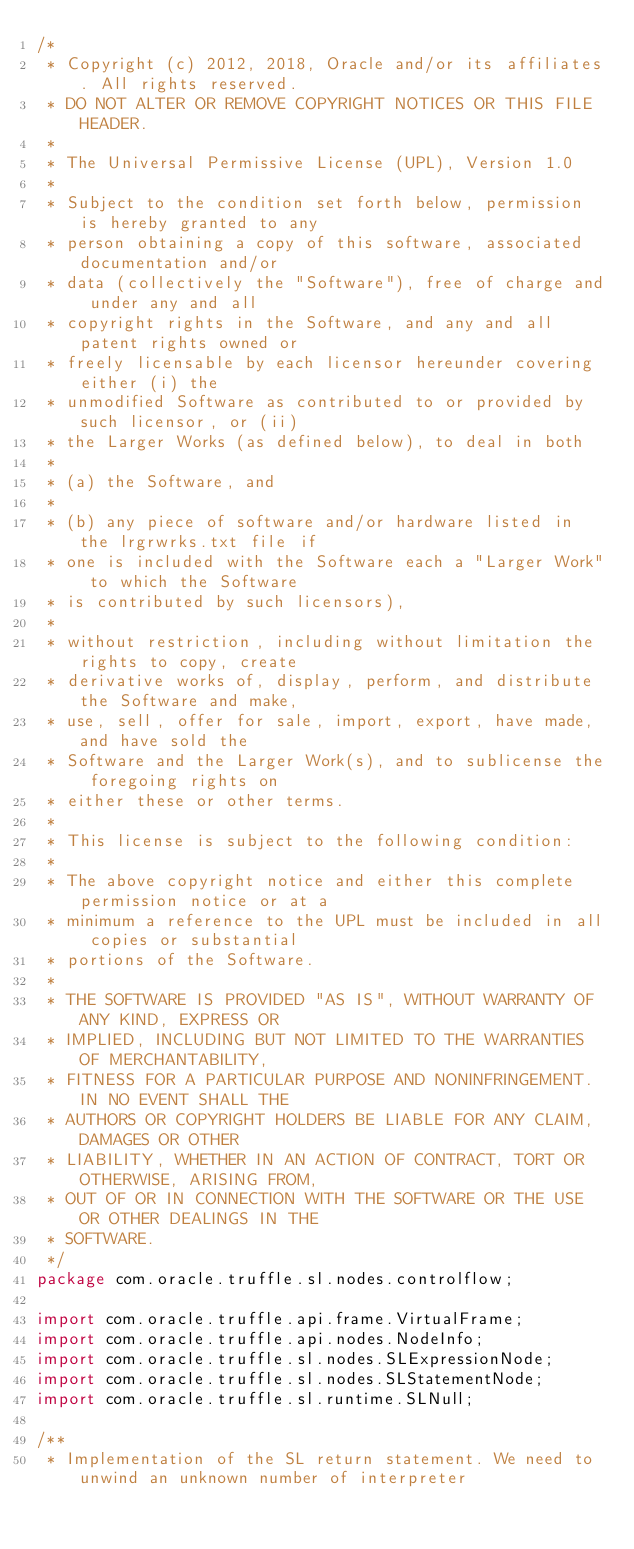Convert code to text. <code><loc_0><loc_0><loc_500><loc_500><_Java_>/*
 * Copyright (c) 2012, 2018, Oracle and/or its affiliates. All rights reserved.
 * DO NOT ALTER OR REMOVE COPYRIGHT NOTICES OR THIS FILE HEADER.
 *
 * The Universal Permissive License (UPL), Version 1.0
 *
 * Subject to the condition set forth below, permission is hereby granted to any
 * person obtaining a copy of this software, associated documentation and/or
 * data (collectively the "Software"), free of charge and under any and all
 * copyright rights in the Software, and any and all patent rights owned or
 * freely licensable by each licensor hereunder covering either (i) the
 * unmodified Software as contributed to or provided by such licensor, or (ii)
 * the Larger Works (as defined below), to deal in both
 *
 * (a) the Software, and
 *
 * (b) any piece of software and/or hardware listed in the lrgrwrks.txt file if
 * one is included with the Software each a "Larger Work" to which the Software
 * is contributed by such licensors),
 *
 * without restriction, including without limitation the rights to copy, create
 * derivative works of, display, perform, and distribute the Software and make,
 * use, sell, offer for sale, import, export, have made, and have sold the
 * Software and the Larger Work(s), and to sublicense the foregoing rights on
 * either these or other terms.
 *
 * This license is subject to the following condition:
 *
 * The above copyright notice and either this complete permission notice or at a
 * minimum a reference to the UPL must be included in all copies or substantial
 * portions of the Software.
 *
 * THE SOFTWARE IS PROVIDED "AS IS", WITHOUT WARRANTY OF ANY KIND, EXPRESS OR
 * IMPLIED, INCLUDING BUT NOT LIMITED TO THE WARRANTIES OF MERCHANTABILITY,
 * FITNESS FOR A PARTICULAR PURPOSE AND NONINFRINGEMENT. IN NO EVENT SHALL THE
 * AUTHORS OR COPYRIGHT HOLDERS BE LIABLE FOR ANY CLAIM, DAMAGES OR OTHER
 * LIABILITY, WHETHER IN AN ACTION OF CONTRACT, TORT OR OTHERWISE, ARISING FROM,
 * OUT OF OR IN CONNECTION WITH THE SOFTWARE OR THE USE OR OTHER DEALINGS IN THE
 * SOFTWARE.
 */
package com.oracle.truffle.sl.nodes.controlflow;

import com.oracle.truffle.api.frame.VirtualFrame;
import com.oracle.truffle.api.nodes.NodeInfo;
import com.oracle.truffle.sl.nodes.SLExpressionNode;
import com.oracle.truffle.sl.nodes.SLStatementNode;
import com.oracle.truffle.sl.runtime.SLNull;

/**
 * Implementation of the SL return statement. We need to unwind an unknown number of interpreter</code> 